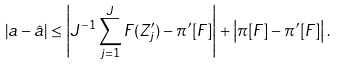Convert formula to latex. <formula><loc_0><loc_0><loc_500><loc_500>| a - \hat { a } | \leq \left | J ^ { - 1 } \sum _ { j = 1 } ^ { J } F ( Z ^ { \prime } _ { j } ) - \pi ^ { \prime } [ F ] \right | + \left | \pi [ F ] - \pi ^ { \prime } [ F ] \right | .</formula> 